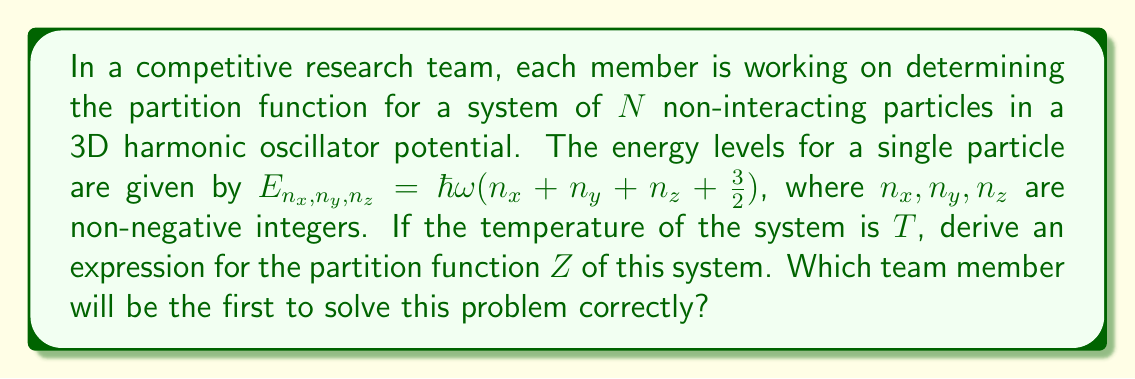Solve this math problem. Let's approach this step-by-step:

1) For a single particle, the partition function $z$ is:

   $$z = \sum_{n_x=0}^{\infty}\sum_{n_y=0}^{\infty}\sum_{n_z=0}^{\infty} e^{-\beta E_{n_x,n_y,n_z}}$$

   where $\beta = \frac{1}{k_B T}$, and $k_B$ is Boltzmann's constant.

2) Substituting the energy levels:

   $$z = \sum_{n_x=0}^{\infty}\sum_{n_y=0}^{\infty}\sum_{n_z=0}^{\infty} e^{-\beta \hbar\omega(n_x + n_y + n_z + \frac{3}{2})}$$

3) This can be rewritten as:

   $$z = e^{-\beta \hbar\omega \frac{3}{2}} \sum_{n_x=0}^{\infty}\sum_{n_y=0}^{\infty}\sum_{n_z=0}^{\infty} e^{-\beta \hbar\omega(n_x + n_y + n_z)}$$

4) The sum can be separated:

   $$z = e^{-\beta \hbar\omega \frac{3}{2}} \left(\sum_{n_x=0}^{\infty} e^{-\beta \hbar\omega n_x}\right) \left(\sum_{n_y=0}^{\infty} e^{-\beta \hbar\omega n_y}\right) \left(\sum_{n_z=0}^{\infty} e^{-\beta \hbar\omega n_z}\right)$$

5) Each sum is a geometric series with ratio $e^{-\beta \hbar\omega}$. The sum of such a series is $\frac{1}{1-e^{-\beta \hbar\omega}}$. So:

   $$z = e^{-\beta \hbar\omega \frac{3}{2}} \left(\frac{1}{1-e^{-\beta \hbar\omega}}\right)^3$$

6) For a system of $N$ non-interacting particles, the total partition function $Z$ is the product of individual partition functions:

   $$Z = z^N = \left[e^{-\beta \hbar\omega \frac{3}{2}} \left(\frac{1}{1-e^{-\beta \hbar\omega}}\right)^3\right]^N$$

7) This can be simplified to:

   $$Z = e^{-\beta \hbar\omega \frac{3N}{2}} \left(\frac{1}{1-e^{-\beta \hbar\omega}}\right)^{3N}$$
Answer: $Z = e^{-\beta \hbar\omega \frac{3N}{2}} \left(\frac{1}{1-e^{-\beta \hbar\omega}}\right)^{3N}$ 